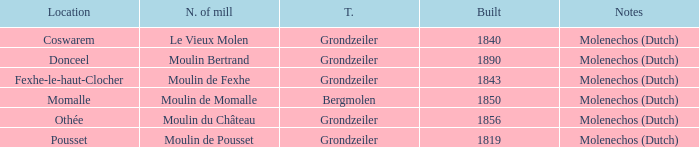What is the Name of the Grondzeiler Mill? Le Vieux Molen, Moulin Bertrand, Moulin de Fexhe, Moulin du Château, Moulin de Pousset. 